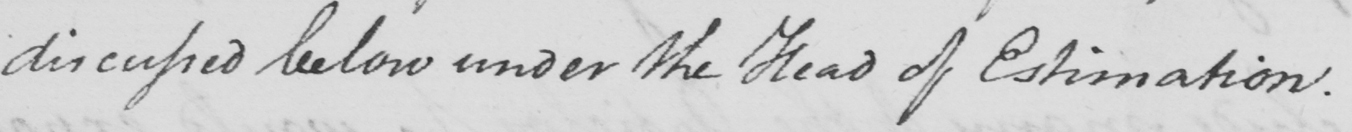Transcribe the text shown in this historical manuscript line. discussed below under the Head of Estimation . 